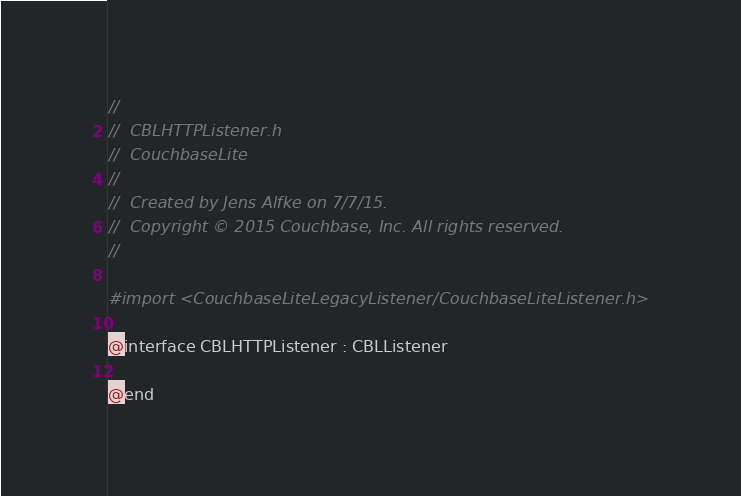<code> <loc_0><loc_0><loc_500><loc_500><_C_>//
//  CBLHTTPListener.h
//  CouchbaseLite
//
//  Created by Jens Alfke on 7/7/15.
//  Copyright © 2015 Couchbase, Inc. All rights reserved.
//

#import <CouchbaseLiteLegacyListener/CouchbaseLiteListener.h>

@interface CBLHTTPListener : CBLListener

@end
</code> 